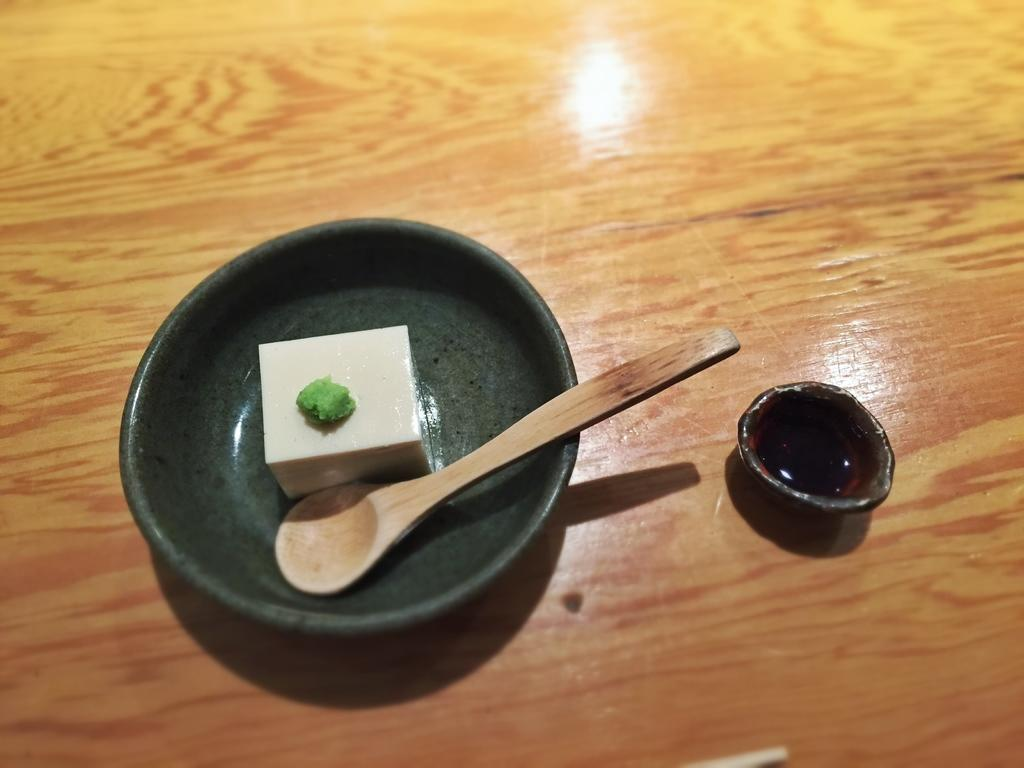What is in the bowl that is visible in the image? There is food in the bowl in the image. What utensil is present in the image? There is a spoon in the image. What other container is visible in the image? There is a cup in the image. What type of brush is being used by the carpenter in the image? There is no carpenter or brush present in the image. 